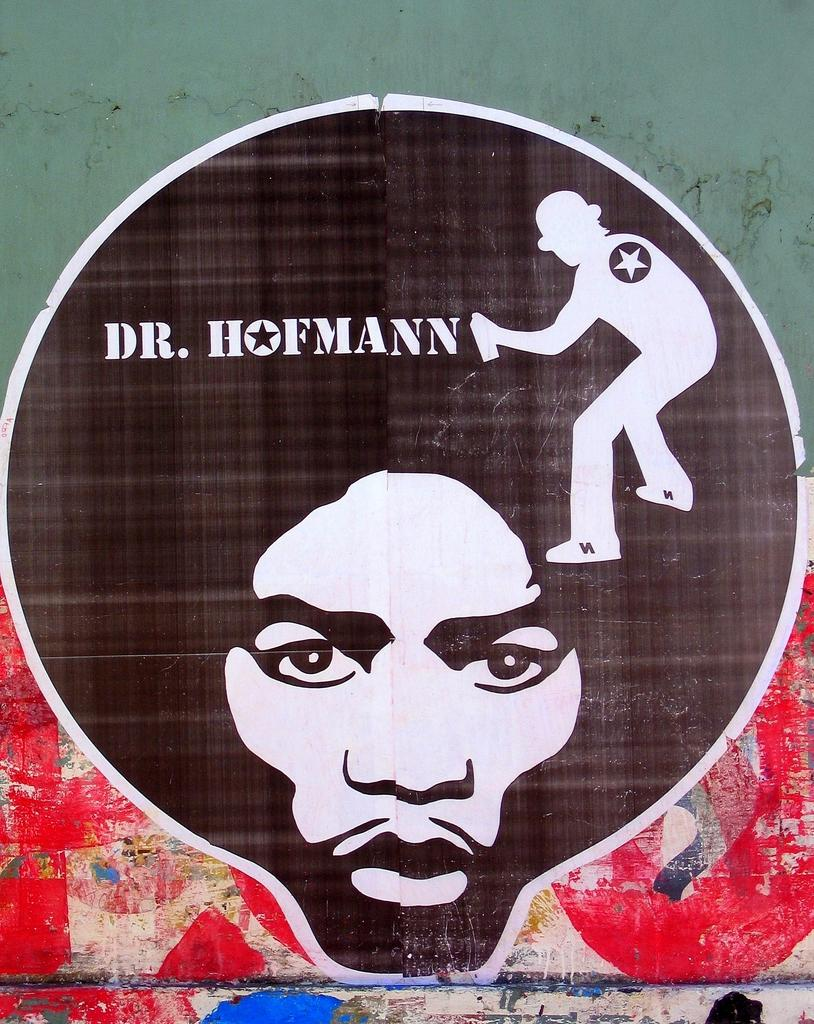What is on the wall in the image? There is a wall with a painting in the image. What else can be seen on the wall besides the painting? There is text and other images on the wall. Can you describe the painting of a person's face on the wall? Yes, there is a painting of a person's face on the wall. What is the person in the painting holding? There is a painting of a person holding an object on the wall. What type of linen is used to create the painting of the person holding an object? There is no information about the materials used to create the painting in the image. Can you tell me how deep the quicksand is in the image? There is no quicksand present in the image. 